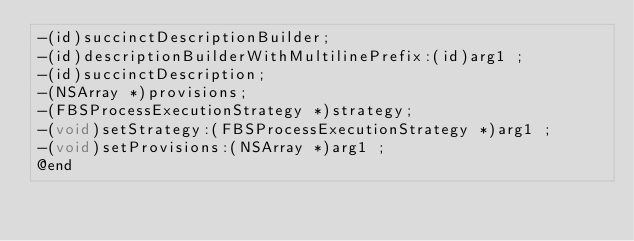<code> <loc_0><loc_0><loc_500><loc_500><_C_>-(id)succinctDescriptionBuilder;
-(id)descriptionBuilderWithMultilinePrefix:(id)arg1 ;
-(id)succinctDescription;
-(NSArray *)provisions;
-(FBSProcessExecutionStrategy *)strategy;
-(void)setStrategy:(FBSProcessExecutionStrategy *)arg1 ;
-(void)setProvisions:(NSArray *)arg1 ;
@end

</code> 